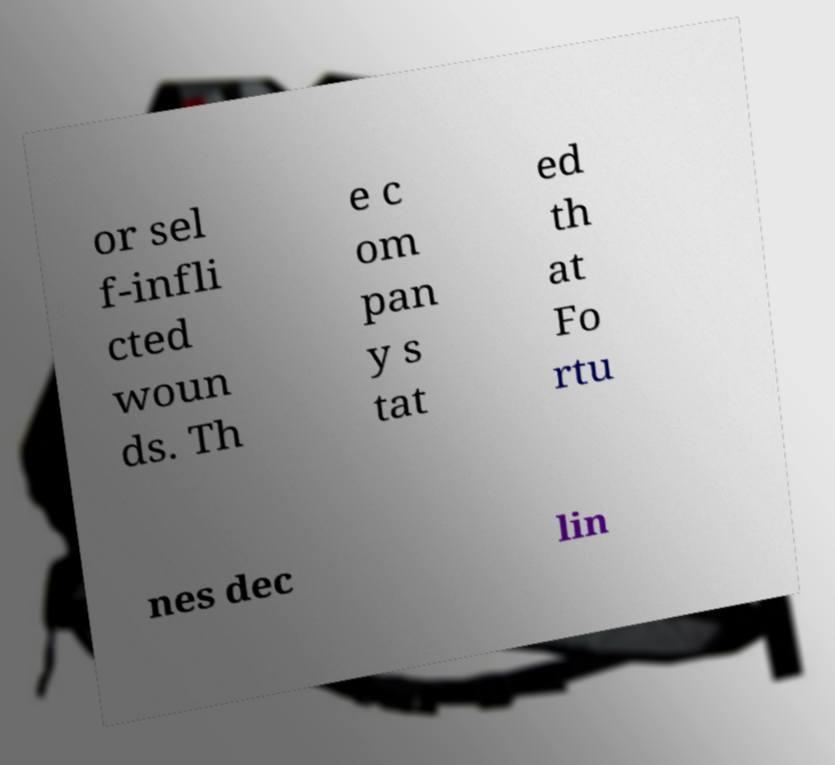Please identify and transcribe the text found in this image. or sel f-infli cted woun ds. Th e c om pan y s tat ed th at Fo rtu nes dec lin 